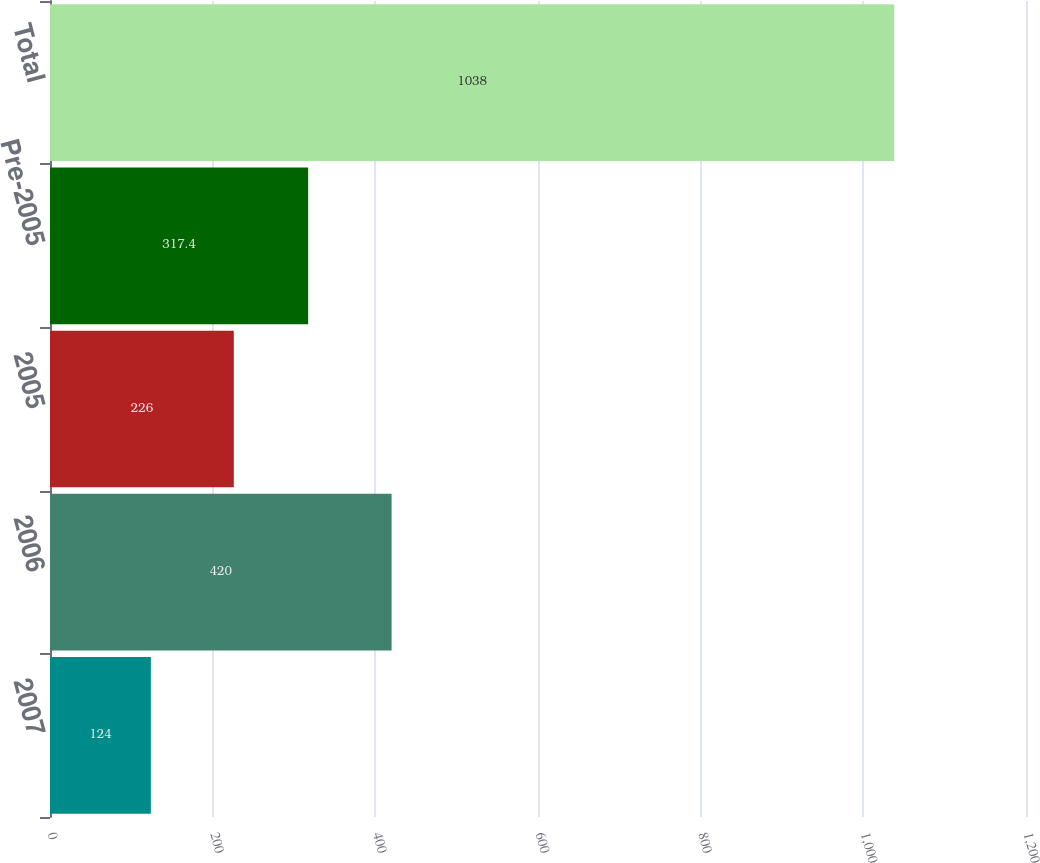Convert chart to OTSL. <chart><loc_0><loc_0><loc_500><loc_500><bar_chart><fcel>2007<fcel>2006<fcel>2005<fcel>Pre-2005<fcel>Total<nl><fcel>124<fcel>420<fcel>226<fcel>317.4<fcel>1038<nl></chart> 